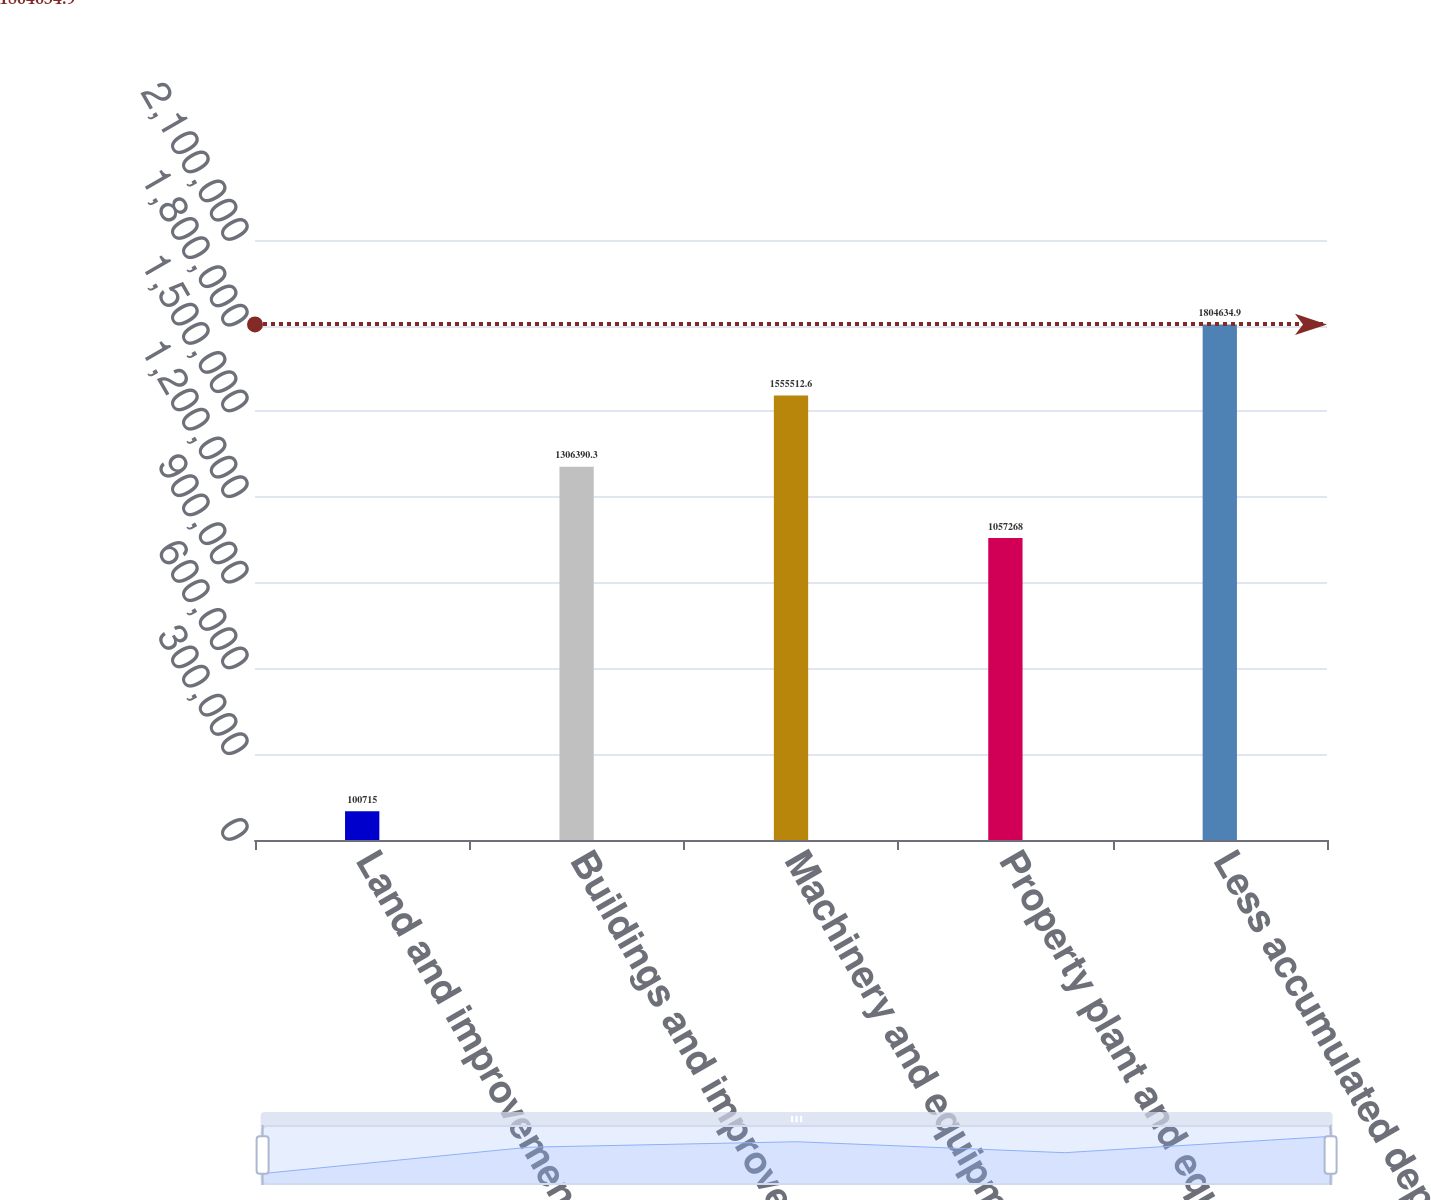Convert chart. <chart><loc_0><loc_0><loc_500><loc_500><bar_chart><fcel>Land and improvements<fcel>Buildings and improvements<fcel>Machinery and equipment<fcel>Property plant and equipment<fcel>Less accumulated depreciation<nl><fcel>100715<fcel>1.30639e+06<fcel>1.55551e+06<fcel>1.05727e+06<fcel>1.80463e+06<nl></chart> 